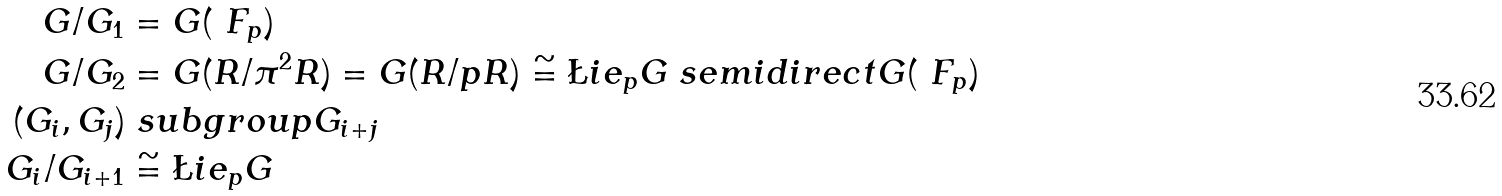<formula> <loc_0><loc_0><loc_500><loc_500>G / G _ { 1 } & = G ( \ F _ { p } ) \\ G / G _ { 2 } & = G ( R / \pi ^ { 2 } R ) = G ( R / p R ) \cong \L i e _ { p } G \ s e m i d i r e c t G ( \ F _ { p } ) \\ ( G _ { i } , G _ { j } ) & \ s u b g r o u p G _ { i + j } \\ G _ { i } / G _ { i + 1 } & \cong \L i e _ { p } G</formula> 